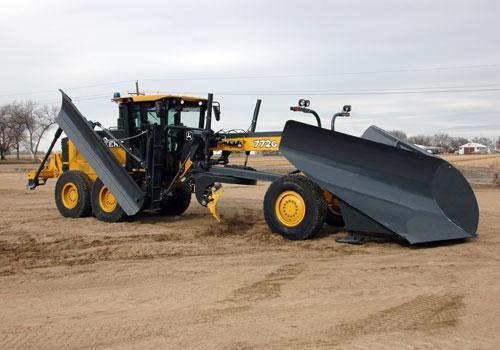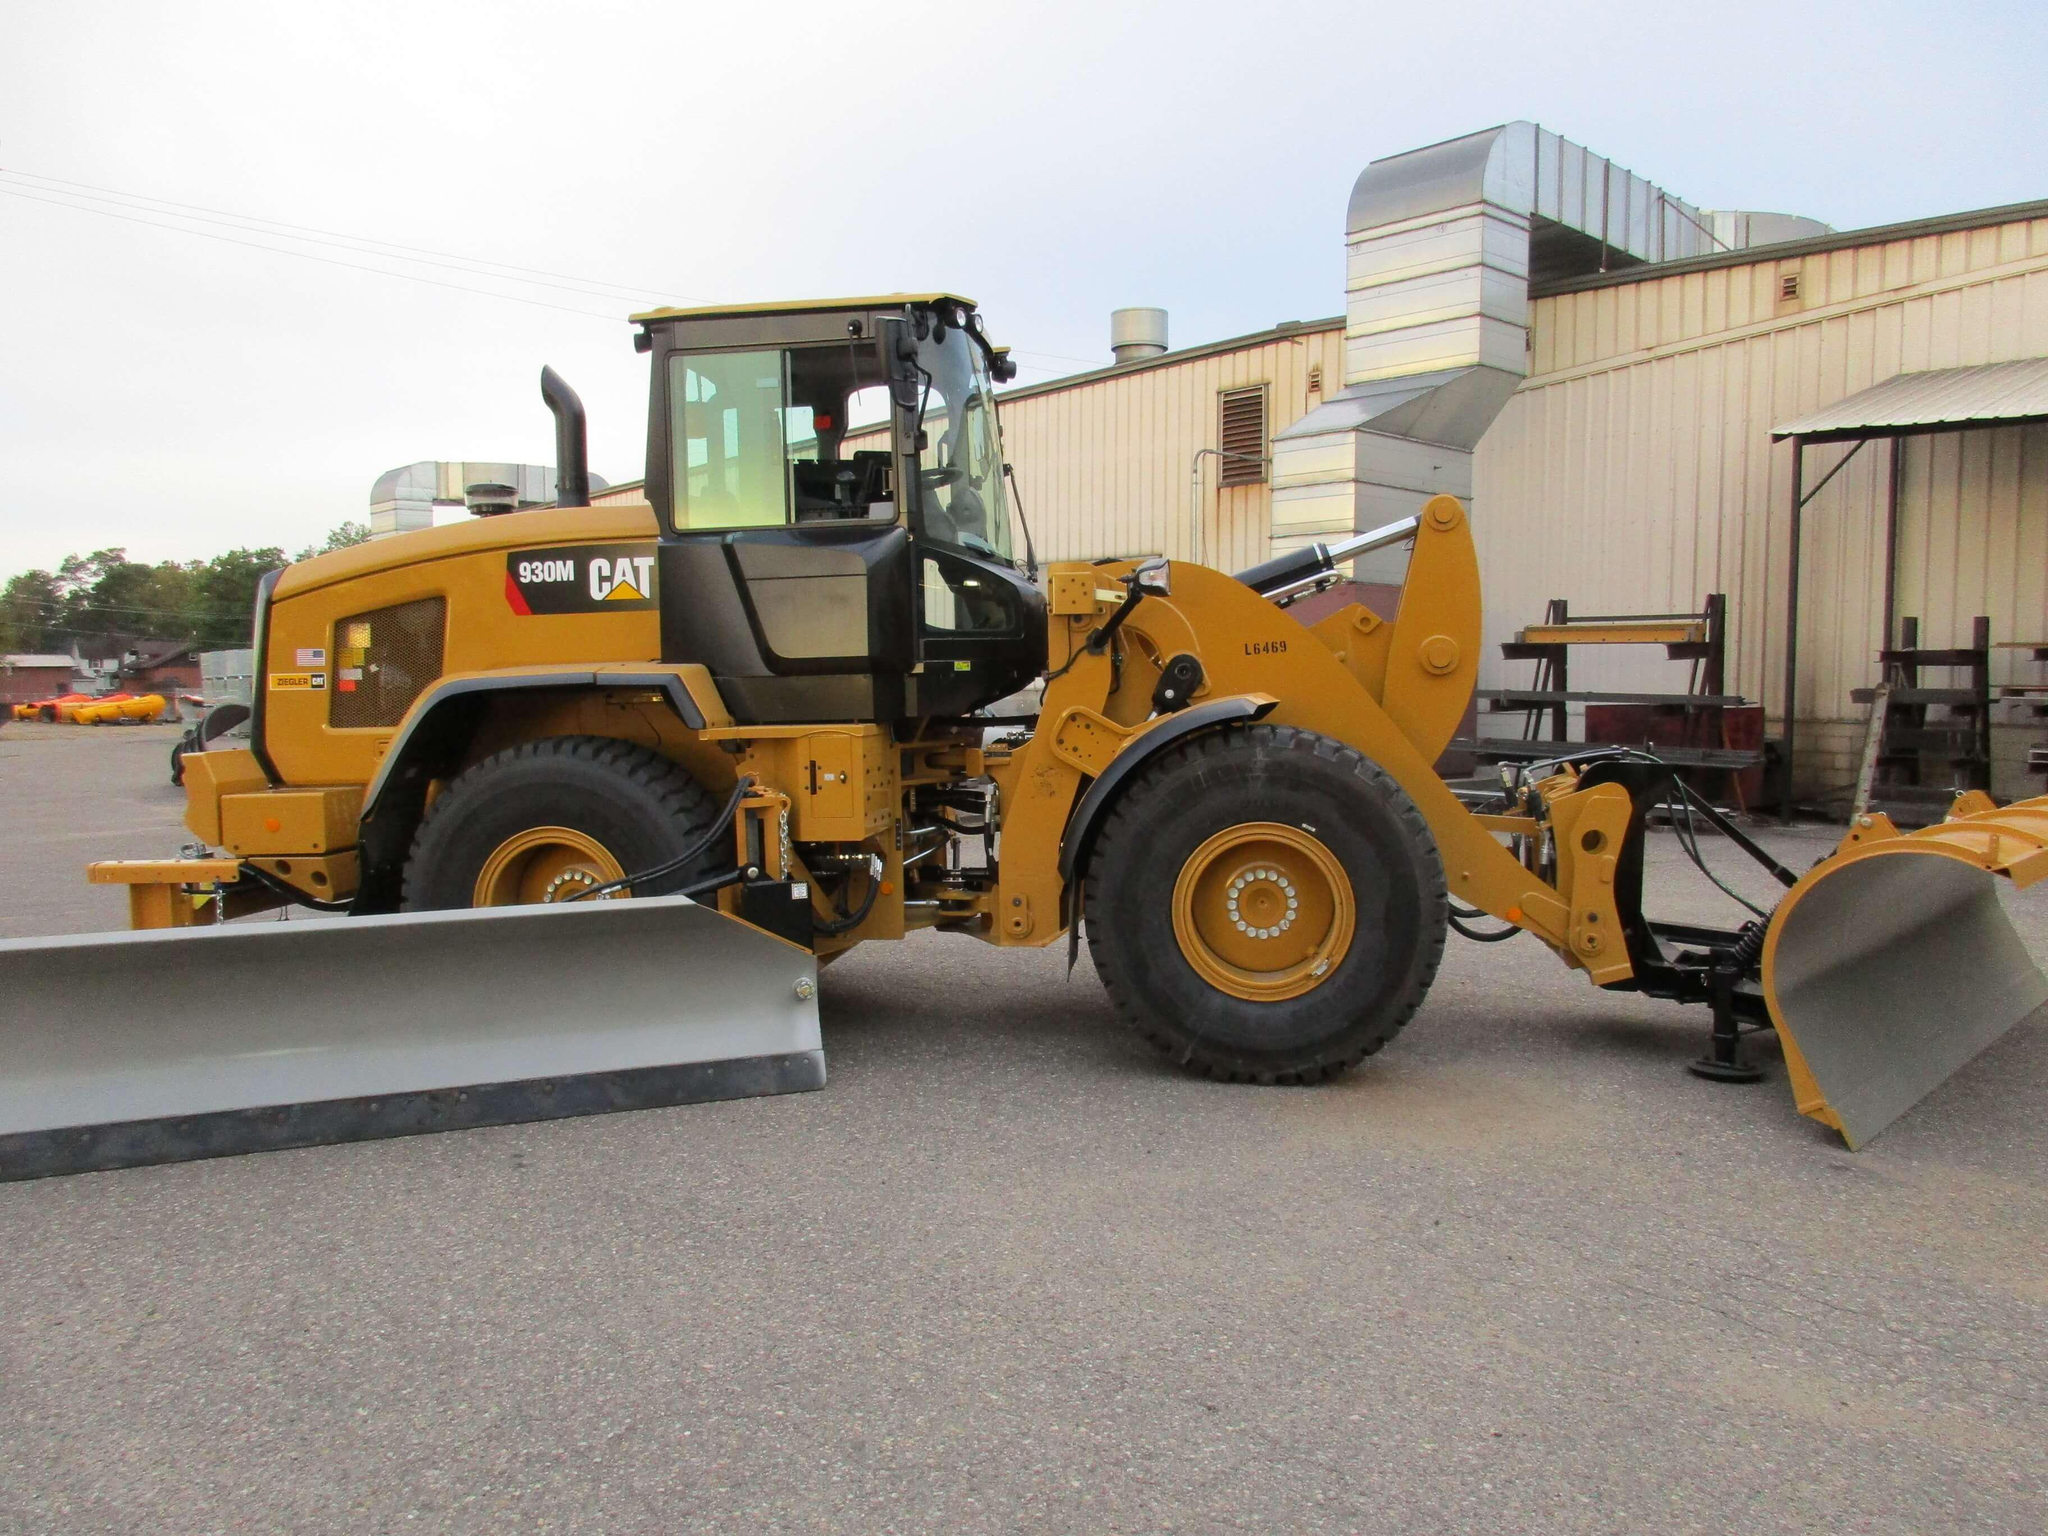The first image is the image on the left, the second image is the image on the right. Considering the images on both sides, is "There is snow in the image on the left." valid? Answer yes or no. No. The first image is the image on the left, the second image is the image on the right. Assess this claim about the two images: "There is a snowplow on a snow-covered surface.". Correct or not? Answer yes or no. No. 